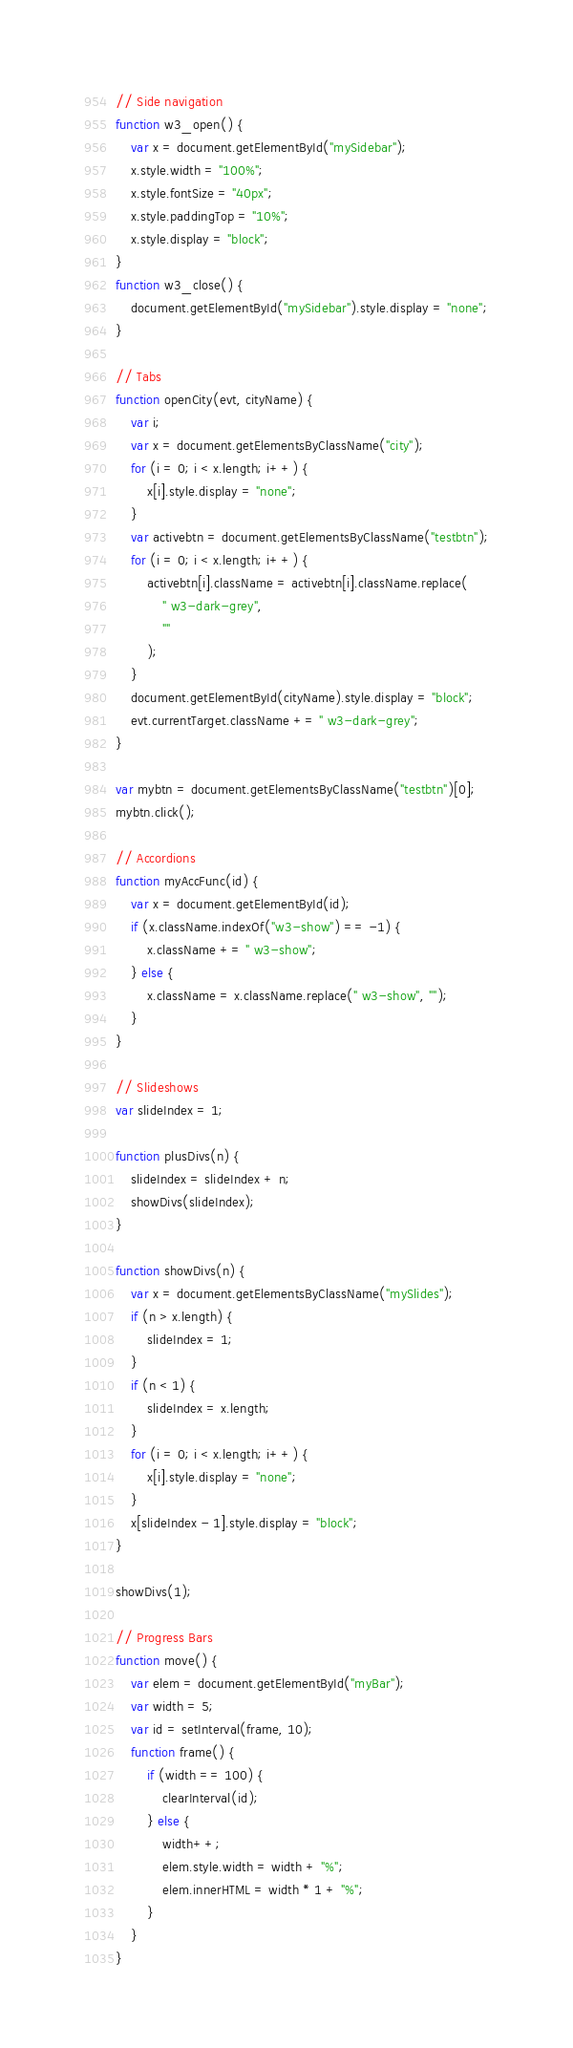Convert code to text. <code><loc_0><loc_0><loc_500><loc_500><_JavaScript_>// Side navigation
function w3_open() {
    var x = document.getElementById("mySidebar");
    x.style.width = "100%";
    x.style.fontSize = "40px";
    x.style.paddingTop = "10%";
    x.style.display = "block";
}
function w3_close() {
    document.getElementById("mySidebar").style.display = "none";
}

// Tabs
function openCity(evt, cityName) {
    var i;
    var x = document.getElementsByClassName("city");
    for (i = 0; i < x.length; i++) {
        x[i].style.display = "none";
    }
    var activebtn = document.getElementsByClassName("testbtn");
    for (i = 0; i < x.length; i++) {
        activebtn[i].className = activebtn[i].className.replace(
            " w3-dark-grey",
            ""
        );
    }
    document.getElementById(cityName).style.display = "block";
    evt.currentTarget.className += " w3-dark-grey";
}

var mybtn = document.getElementsByClassName("testbtn")[0];
mybtn.click();

// Accordions
function myAccFunc(id) {
    var x = document.getElementById(id);
    if (x.className.indexOf("w3-show") == -1) {
        x.className += " w3-show";
    } else {
        x.className = x.className.replace(" w3-show", "");
    }
}

// Slideshows
var slideIndex = 1;

function plusDivs(n) {
    slideIndex = slideIndex + n;
    showDivs(slideIndex);
}

function showDivs(n) {
    var x = document.getElementsByClassName("mySlides");
    if (n > x.length) {
        slideIndex = 1;
    }
    if (n < 1) {
        slideIndex = x.length;
    }
    for (i = 0; i < x.length; i++) {
        x[i].style.display = "none";
    }
    x[slideIndex - 1].style.display = "block";
}

showDivs(1);

// Progress Bars
function move() {
    var elem = document.getElementById("myBar");
    var width = 5;
    var id = setInterval(frame, 10);
    function frame() {
        if (width == 100) {
            clearInterval(id);
        } else {
            width++;
            elem.style.width = width + "%";
            elem.innerHTML = width * 1 + "%";
        }
    }
}
</code> 